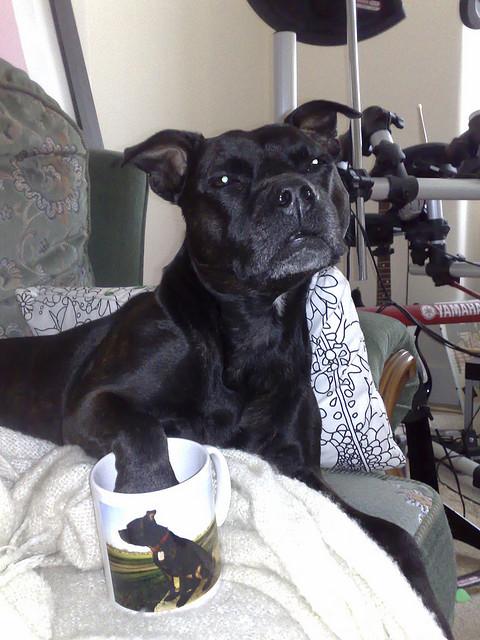What animal is painted on the side of the cup?
Concise answer only. Dog. What color is the blanket?
Answer briefly. White. Is the dog bathing his paw?
Answer briefly. No. 